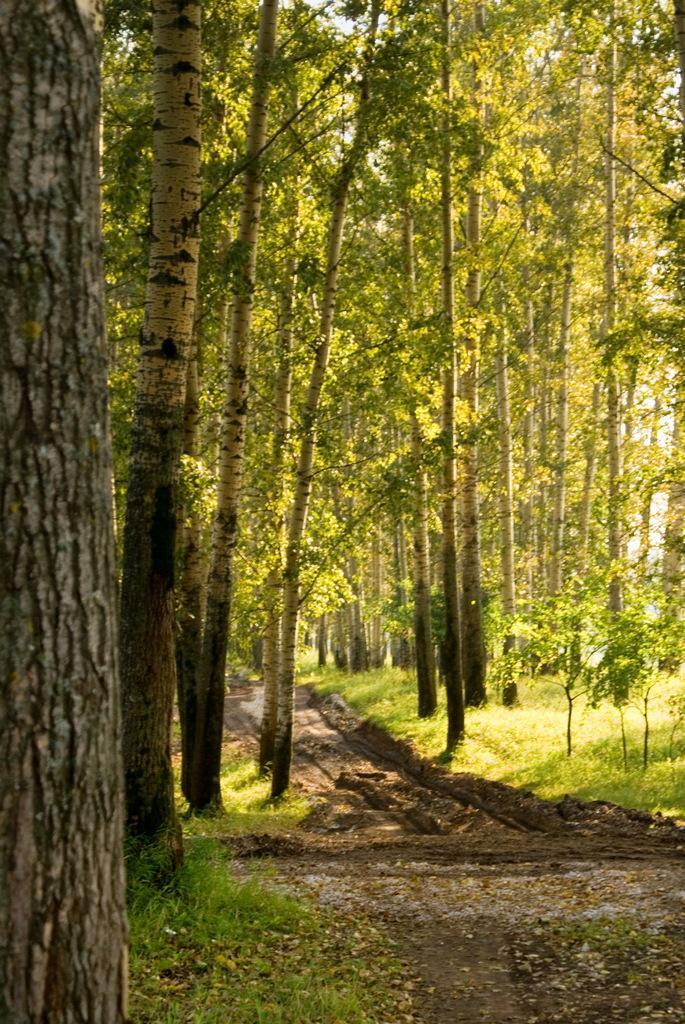In one or two sentences, can you explain what this image depicts? In this image we can see there are some trees, grass and leaves on the ground, also we can see the sky. 